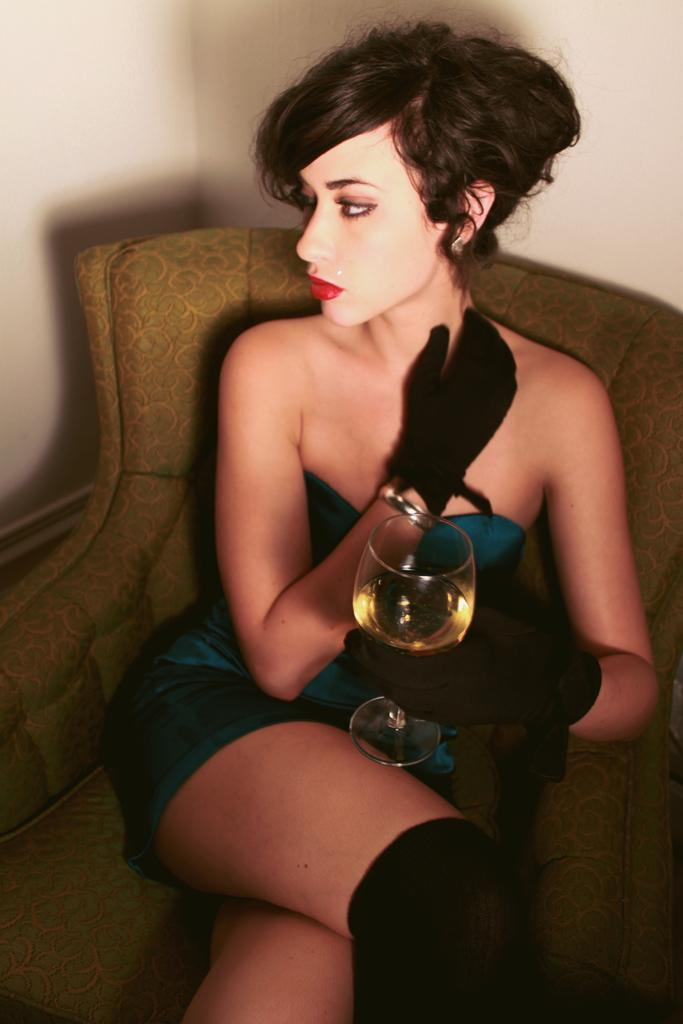Who is the main subject in the image? There is a woman in the image. What is the woman doing in the image? The woman is sitting on a chair. What is the woman holding in her hand? The woman is holding a glass in her hand. What can be seen in the background of the image? There is a wall in the background of the image. What type of pot is the woman using to balance on her tail in the image? There is no pot or tail present in the image; the woman is simply sitting on a chair and holding a glass. 